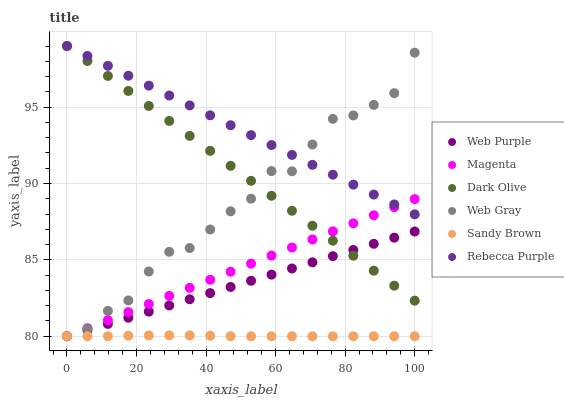Does Sandy Brown have the minimum area under the curve?
Answer yes or no. Yes. Does Rebecca Purple have the maximum area under the curve?
Answer yes or no. Yes. Does Dark Olive have the minimum area under the curve?
Answer yes or no. No. Does Dark Olive have the maximum area under the curve?
Answer yes or no. No. Is Magenta the smoothest?
Answer yes or no. Yes. Is Web Gray the roughest?
Answer yes or no. Yes. Is Dark Olive the smoothest?
Answer yes or no. No. Is Dark Olive the roughest?
Answer yes or no. No. Does Web Gray have the lowest value?
Answer yes or no. Yes. Does Dark Olive have the lowest value?
Answer yes or no. No. Does Rebecca Purple have the highest value?
Answer yes or no. Yes. Does Web Purple have the highest value?
Answer yes or no. No. Is Sandy Brown less than Dark Olive?
Answer yes or no. Yes. Is Dark Olive greater than Sandy Brown?
Answer yes or no. Yes. Does Web Gray intersect Rebecca Purple?
Answer yes or no. Yes. Is Web Gray less than Rebecca Purple?
Answer yes or no. No. Is Web Gray greater than Rebecca Purple?
Answer yes or no. No. Does Sandy Brown intersect Dark Olive?
Answer yes or no. No. 